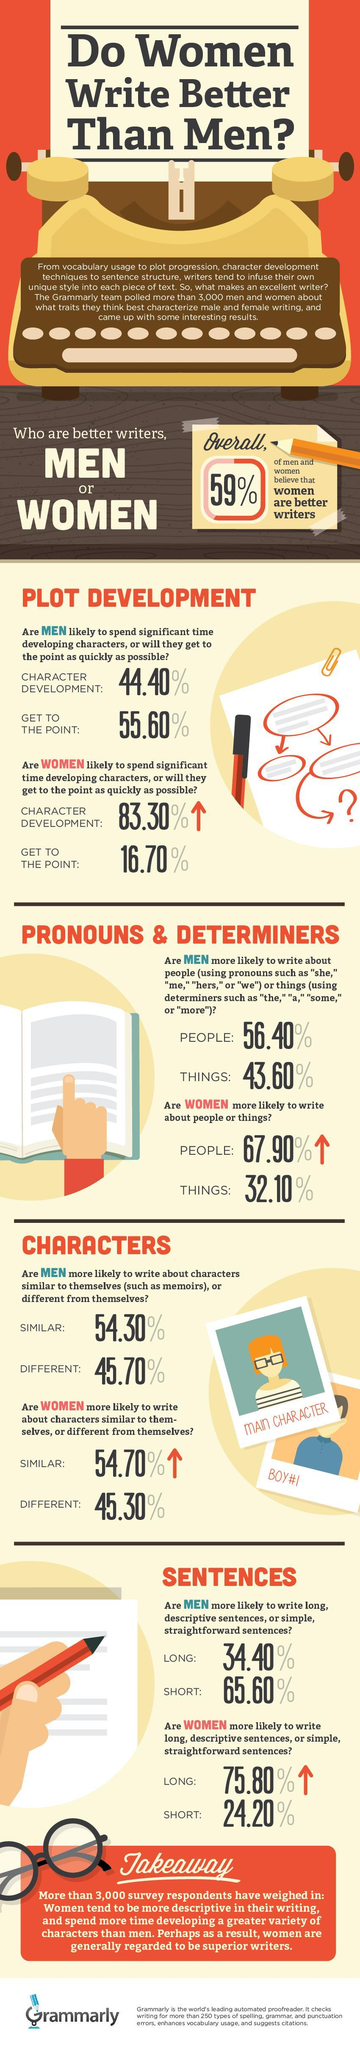Who are likely to spend more time developing characters, men or women?
Answer the question with a short phrase. Women What percent of men are more likely to write memoirs? 54.30% Who are more likely to write longer and more descriptive sentences? Women What percent of women are likely to write simple, straightforward sentences? 24.20% Who are more likely to write about people? Women What percent of men are likely to write longer and more descriptive sentences? 34.40% Who are more likely to write about characters similar to themselves? Women What percent of women spend more time developing characters? 83.30% What percent of the respondents do not believe that women are better writers? 41% Who are more likely to write about things? Men 